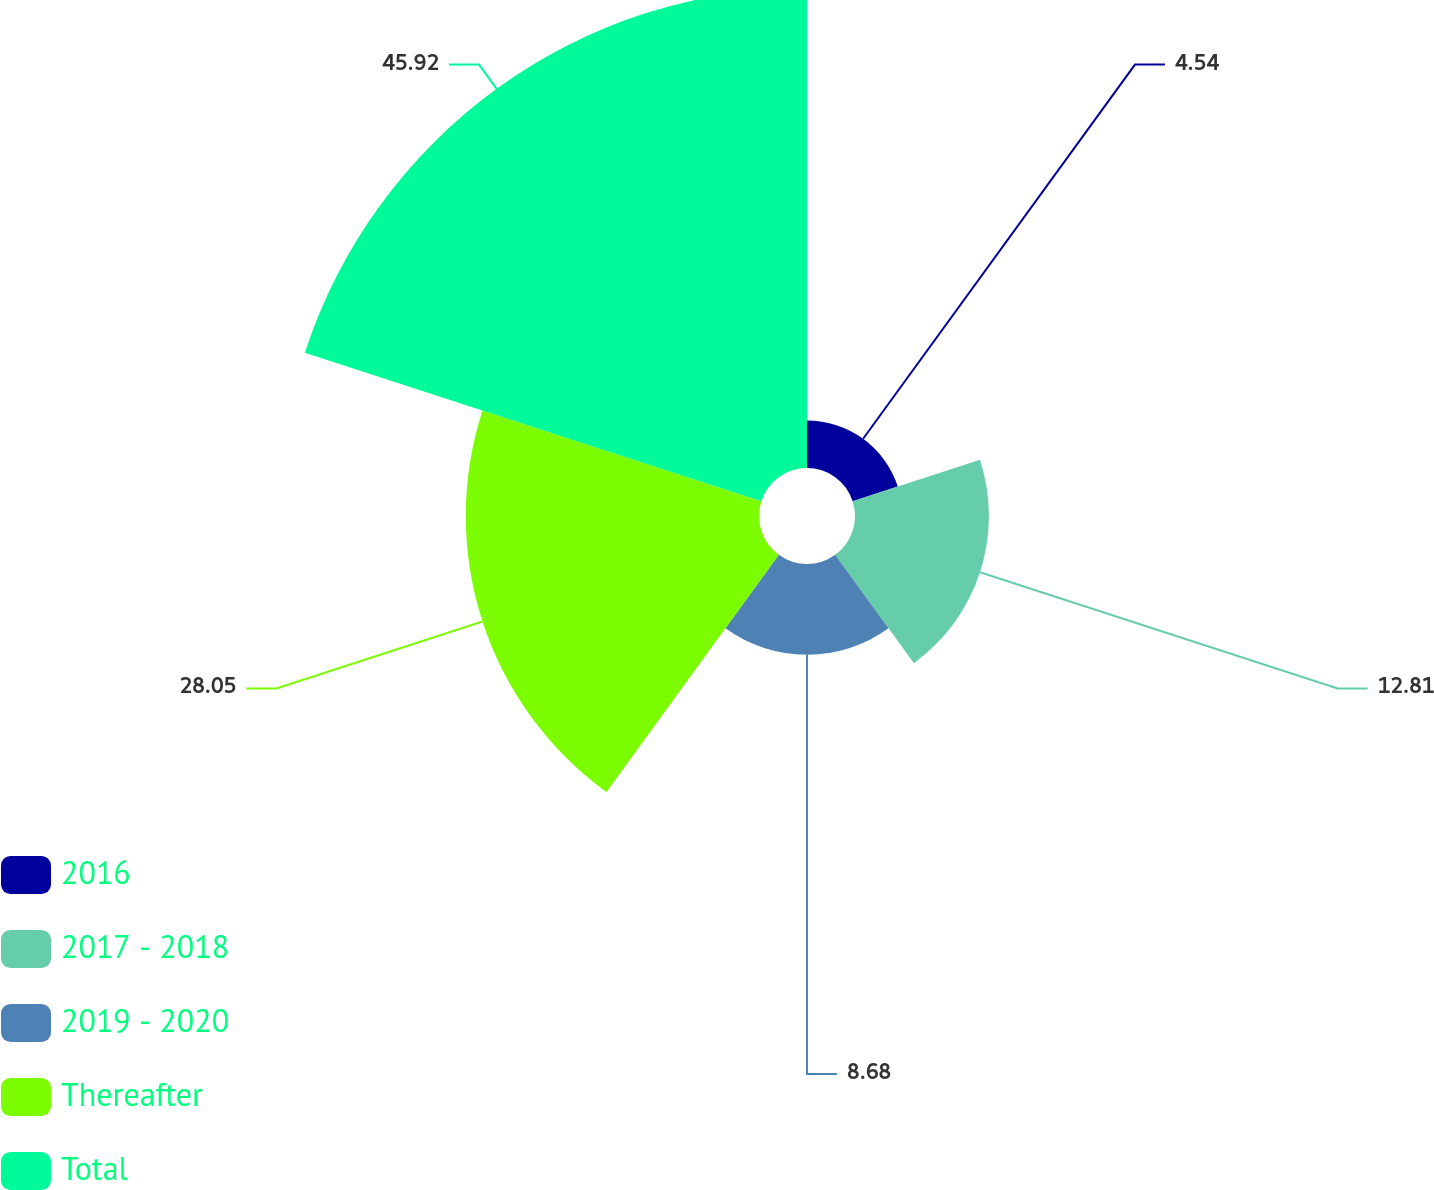<chart> <loc_0><loc_0><loc_500><loc_500><pie_chart><fcel>2016<fcel>2017 - 2018<fcel>2019 - 2020<fcel>Thereafter<fcel>Total<nl><fcel>4.54%<fcel>12.81%<fcel>8.68%<fcel>28.05%<fcel>45.92%<nl></chart> 